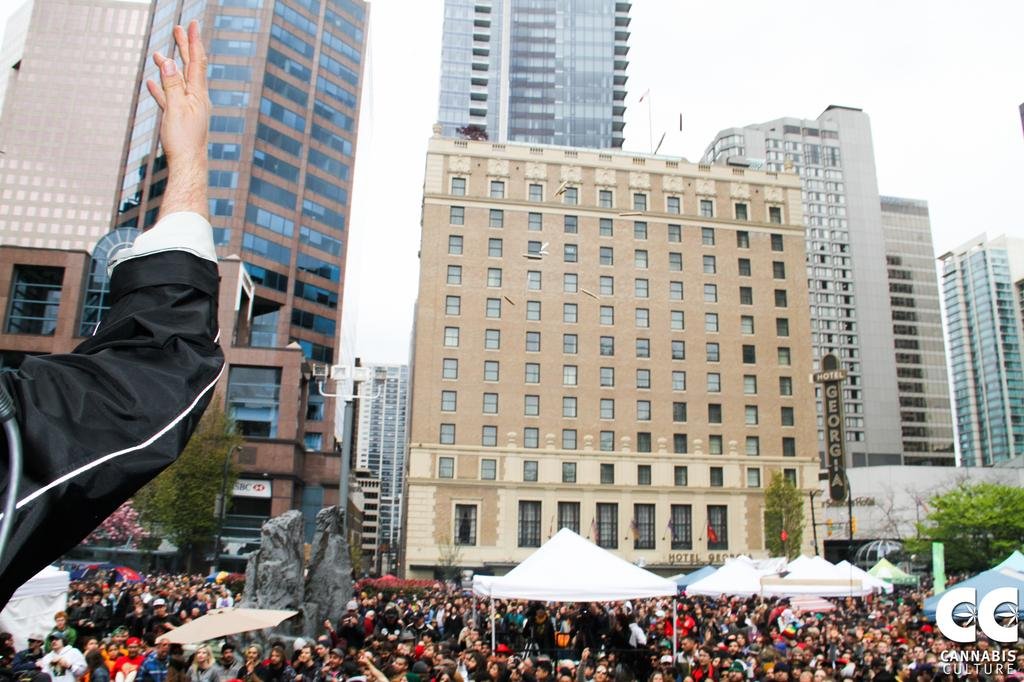What types of subjects can be seen in the image? There are people, statues, an umbrella, trees, a board, a light pole, tents, buildings, and the sky visible in the image. Can you describe the setting of the image? The image features a mix of natural elements, such as trees, and man-made structures, like buildings and statues. There are also tents and a board, which might suggest an outdoor event or gathering. What is the weather like in the image? The sky is visible in the image, but there is no specific information about the weather. However, the presence of an umbrella might suggest that it could be raining or sunny. Are there any symbols or logos in the image? Yes, there is a watermark and a logo present in the image. What riddle is being solved by the people in the image? There is no riddle being solved by the people in the image; they are simply present in the scene with other subjects and objects. What type of voyage are the statues embarking on in the image? The statues are not embarking on any voyage in the image; they are stationary and part of the scene. 